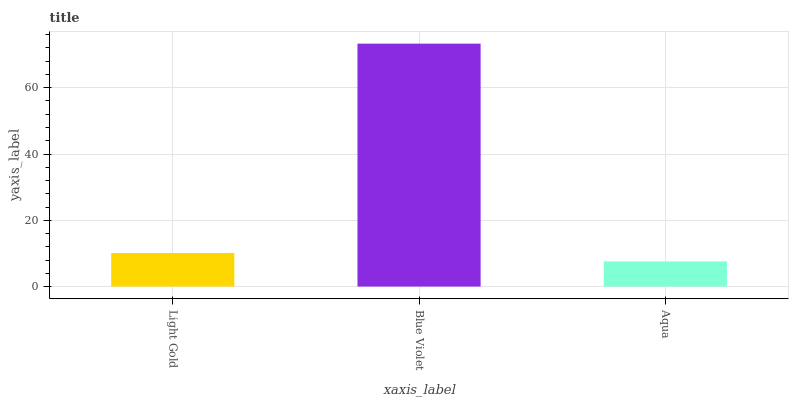Is Aqua the minimum?
Answer yes or no. Yes. Is Blue Violet the maximum?
Answer yes or no. Yes. Is Blue Violet the minimum?
Answer yes or no. No. Is Aqua the maximum?
Answer yes or no. No. Is Blue Violet greater than Aqua?
Answer yes or no. Yes. Is Aqua less than Blue Violet?
Answer yes or no. Yes. Is Aqua greater than Blue Violet?
Answer yes or no. No. Is Blue Violet less than Aqua?
Answer yes or no. No. Is Light Gold the high median?
Answer yes or no. Yes. Is Light Gold the low median?
Answer yes or no. Yes. Is Aqua the high median?
Answer yes or no. No. Is Aqua the low median?
Answer yes or no. No. 